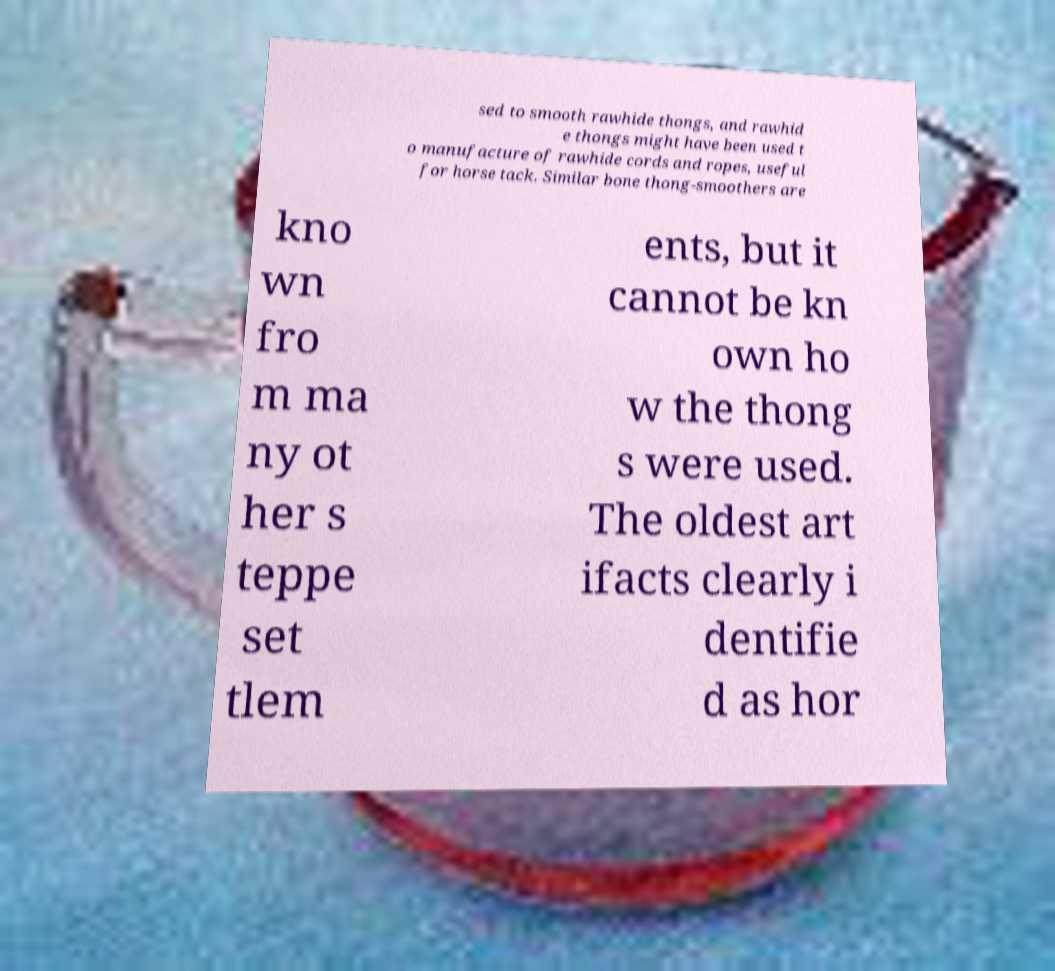Please read and relay the text visible in this image. What does it say? sed to smooth rawhide thongs, and rawhid e thongs might have been used t o manufacture of rawhide cords and ropes, useful for horse tack. Similar bone thong-smoothers are kno wn fro m ma ny ot her s teppe set tlem ents, but it cannot be kn own ho w the thong s were used. The oldest art ifacts clearly i dentifie d as hor 